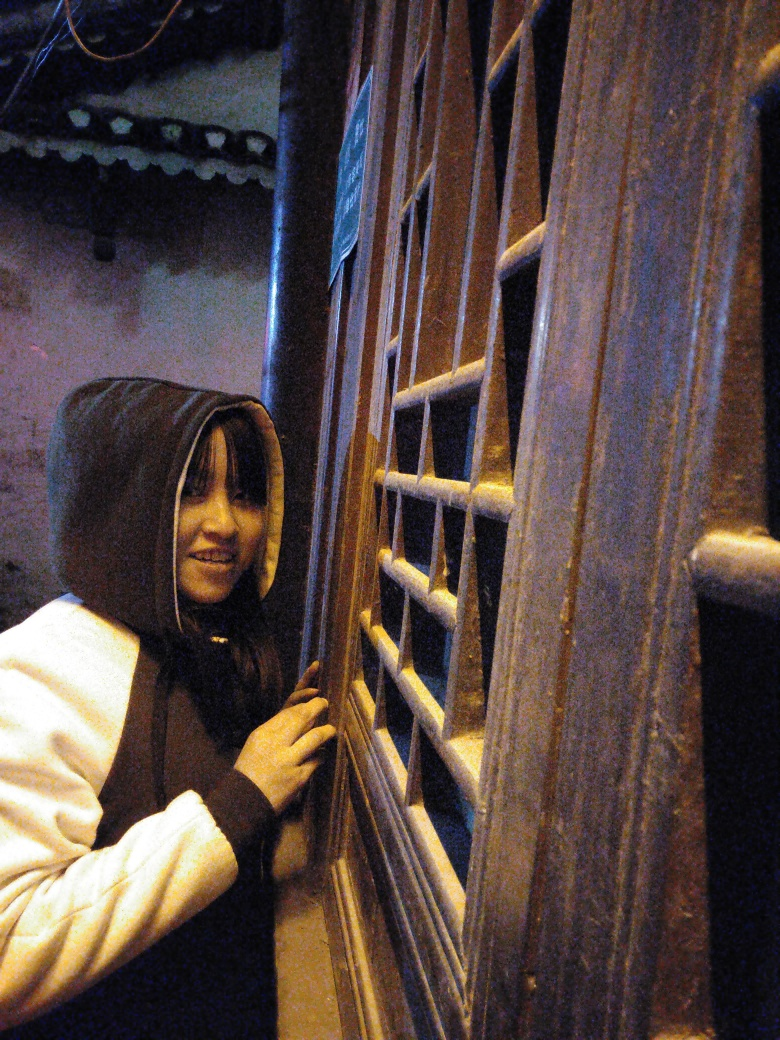What could be the function of these window bars? The window bars likely serve as a security feature, preventing unauthorized entry while allowing visibility and some light to pass through. They also add an architectural aesthetic to the window. 